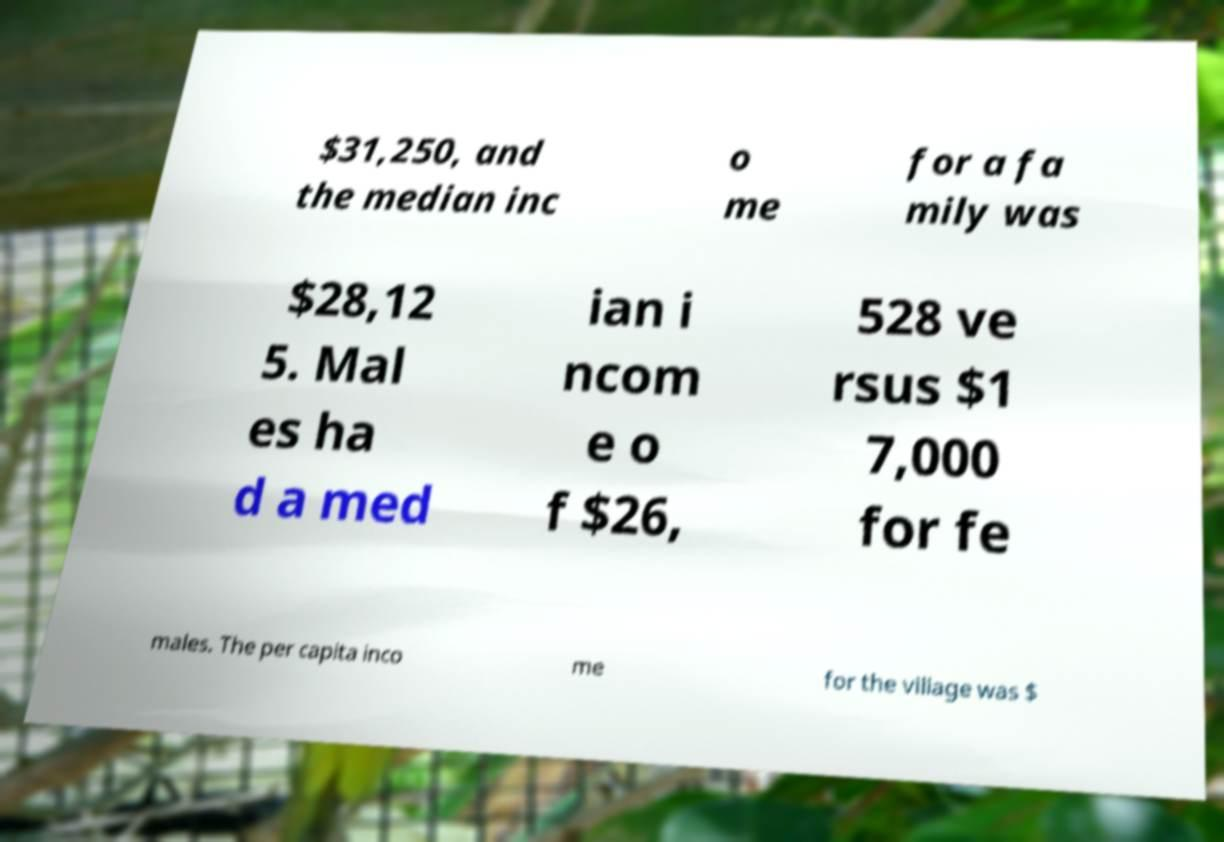There's text embedded in this image that I need extracted. Can you transcribe it verbatim? $31,250, and the median inc o me for a fa mily was $28,12 5. Mal es ha d a med ian i ncom e o f $26, 528 ve rsus $1 7,000 for fe males. The per capita inco me for the village was $ 